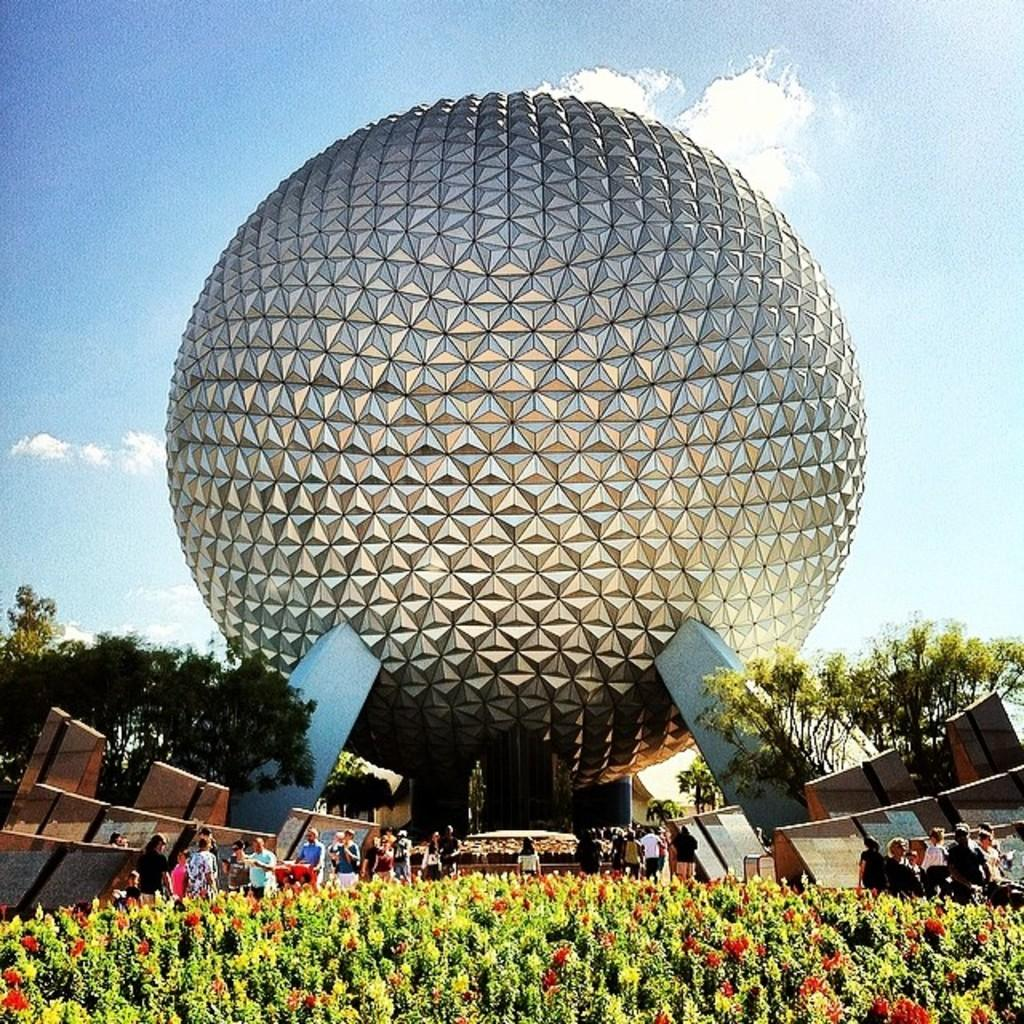What object made of metal can be seen in the image? There is a metal ball in the image. What type of natural vegetation is present in the image? There are trees, plants, and flowers in the image. Are there any living beings in the image? Yes, there are people in the image. What can be seen in the background of the image? The sky is visible in the background of the image, and there are clouds in the sky. How many oranges are being used for pleasure in the image? There are no oranges or references to pleasure present in the image. 